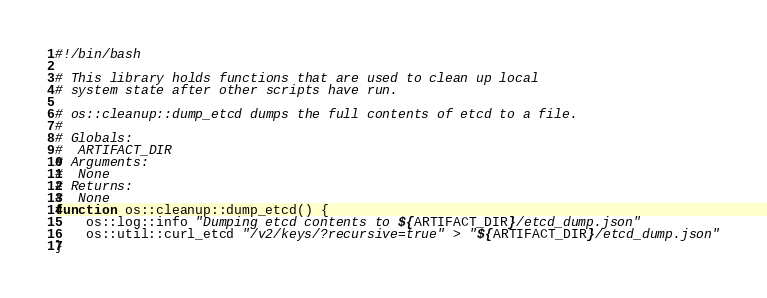Convert code to text. <code><loc_0><loc_0><loc_500><loc_500><_Bash_>#!/bin/bash

# This library holds functions that are used to clean up local
# system state after other scripts have run.

# os::cleanup::dump_etcd dumps the full contents of etcd to a file.
#
# Globals:
#  ARTIFACT_DIR
# Arguments:
#  None
# Returns:
#  None
function os::cleanup::dump_etcd() {
	os::log::info "Dumping etcd contents to ${ARTIFACT_DIR}/etcd_dump.json"
	os::util::curl_etcd "/v2/keys/?recursive=true" > "${ARTIFACT_DIR}/etcd_dump.json"
}</code> 